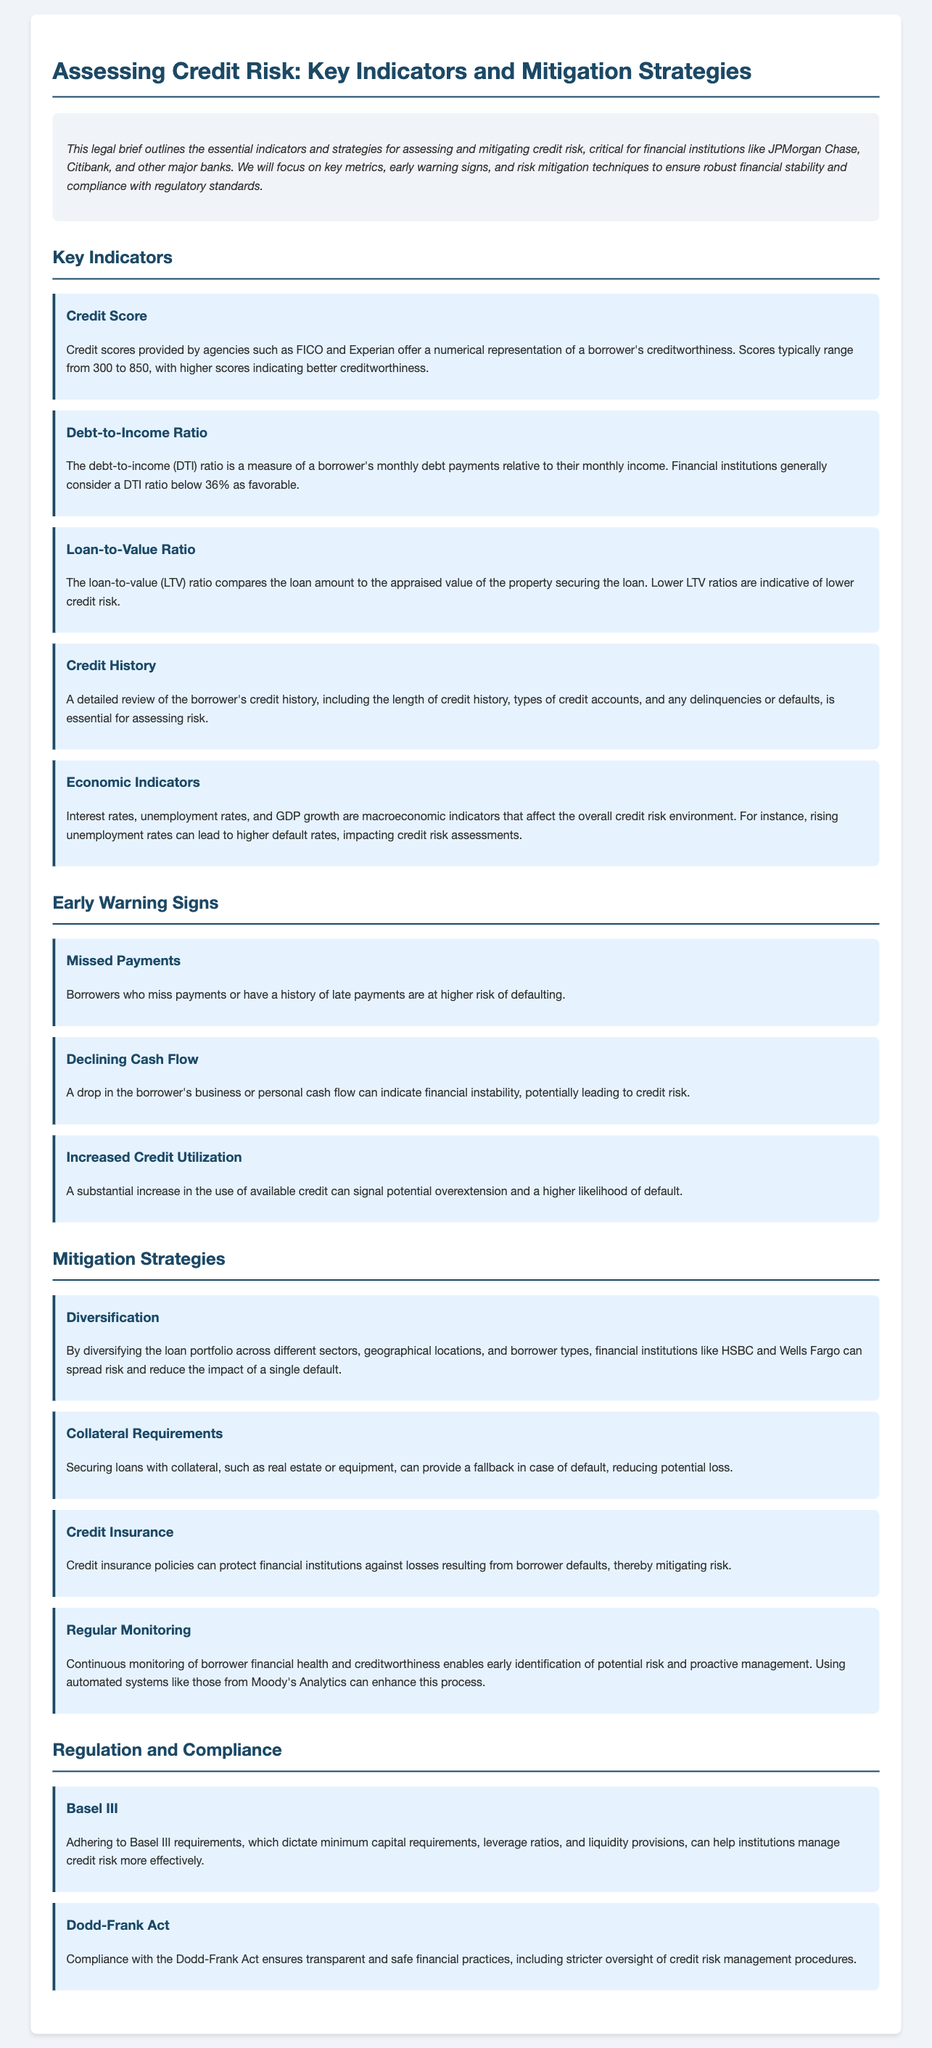What is the title of the document? The title of the document is stated at the top of the document.
Answer: Assessing Credit Risk: Key Indicators and Mitigation Strategies What is the range of credit scores? The document specifies the typical range to assess creditworthiness through credit scores.
Answer: 300 to 850 What is considered a favorable debt-to-income ratio? The document mentions what is generally accepted as a good debt-to-income ratio.
Answer: Below 36% Which credit scoring agency is mentioned? The document references a specific agency for credit scores.
Answer: FICO What early warning sign indicates a higher risk of default? The section on early warning signs highlights a key indicator of credit risk.
Answer: Missed Payments What mitigation strategy involves securing loans? The document describes a specific approach to minimize loss in case of default.
Answer: Collateral Requirements What regulatory framework is referenced for managing credit risk? The document includes specific regulations that aid in credit risk management.
Answer: Basel III How often should borrower financial health be monitored? The document suggests the frequency of monitoring to manage potential risks proactively.
Answer: Regularly What act ensures transparency in financial practices? The document identifies legislation aimed at enhancing financial transparency.
Answer: Dodd-Frank Act 